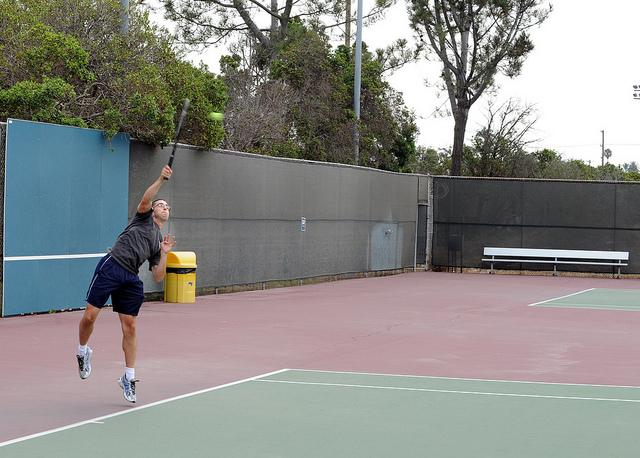Why is his arm raised so high? Please explain your reasoning. hit ball. When playing tennis you have to raise your arm in order to return the ball. 